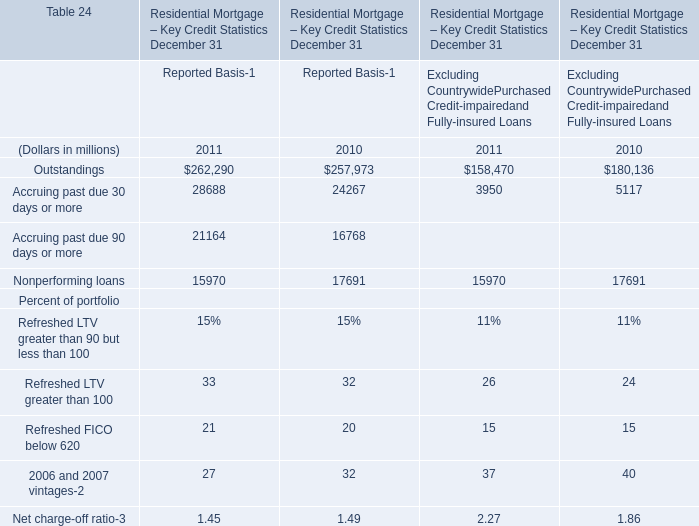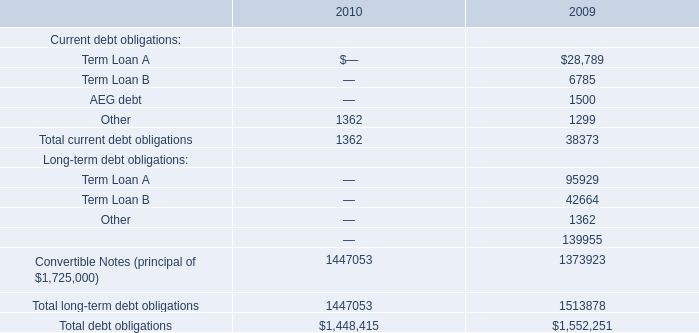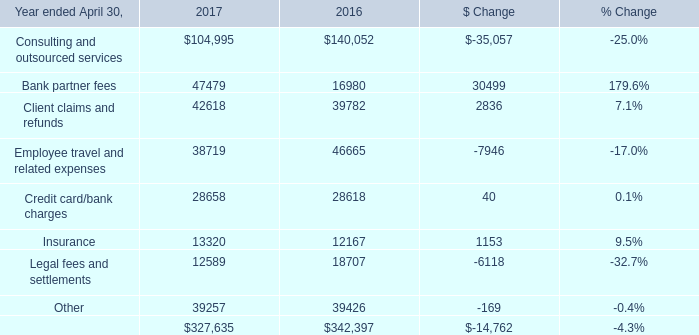Between 2011 and 2010, which year has the fastest decreasing rate for Reported Basis? 
Answer: 2010. 